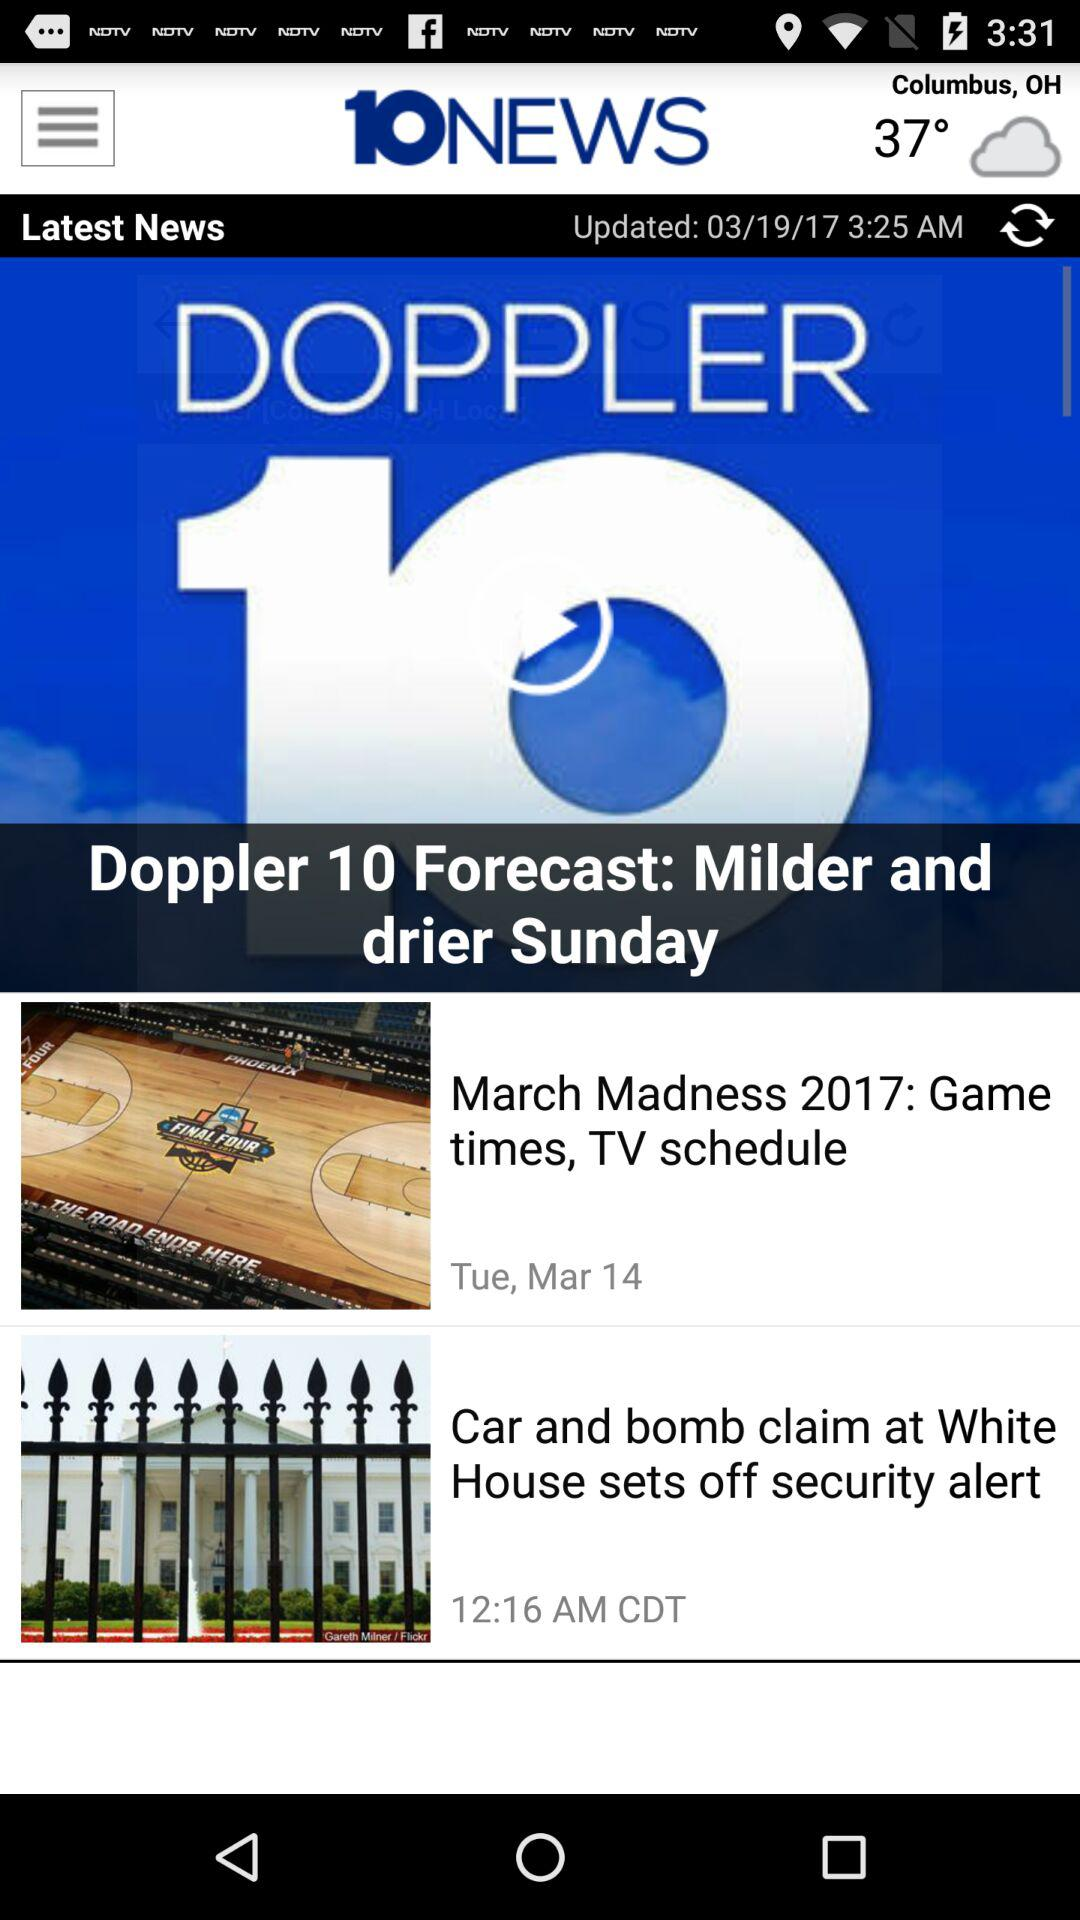When was the article updated? The article was updated on March 19, 2017 at 3:25 AM. 